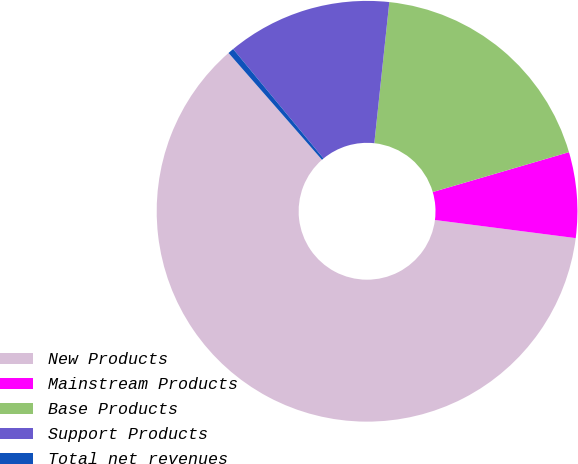Convert chart. <chart><loc_0><loc_0><loc_500><loc_500><pie_chart><fcel>New Products<fcel>Mainstream Products<fcel>Base Products<fcel>Support Products<fcel>Total net revenues<nl><fcel>61.52%<fcel>6.57%<fcel>18.78%<fcel>12.67%<fcel>0.46%<nl></chart> 